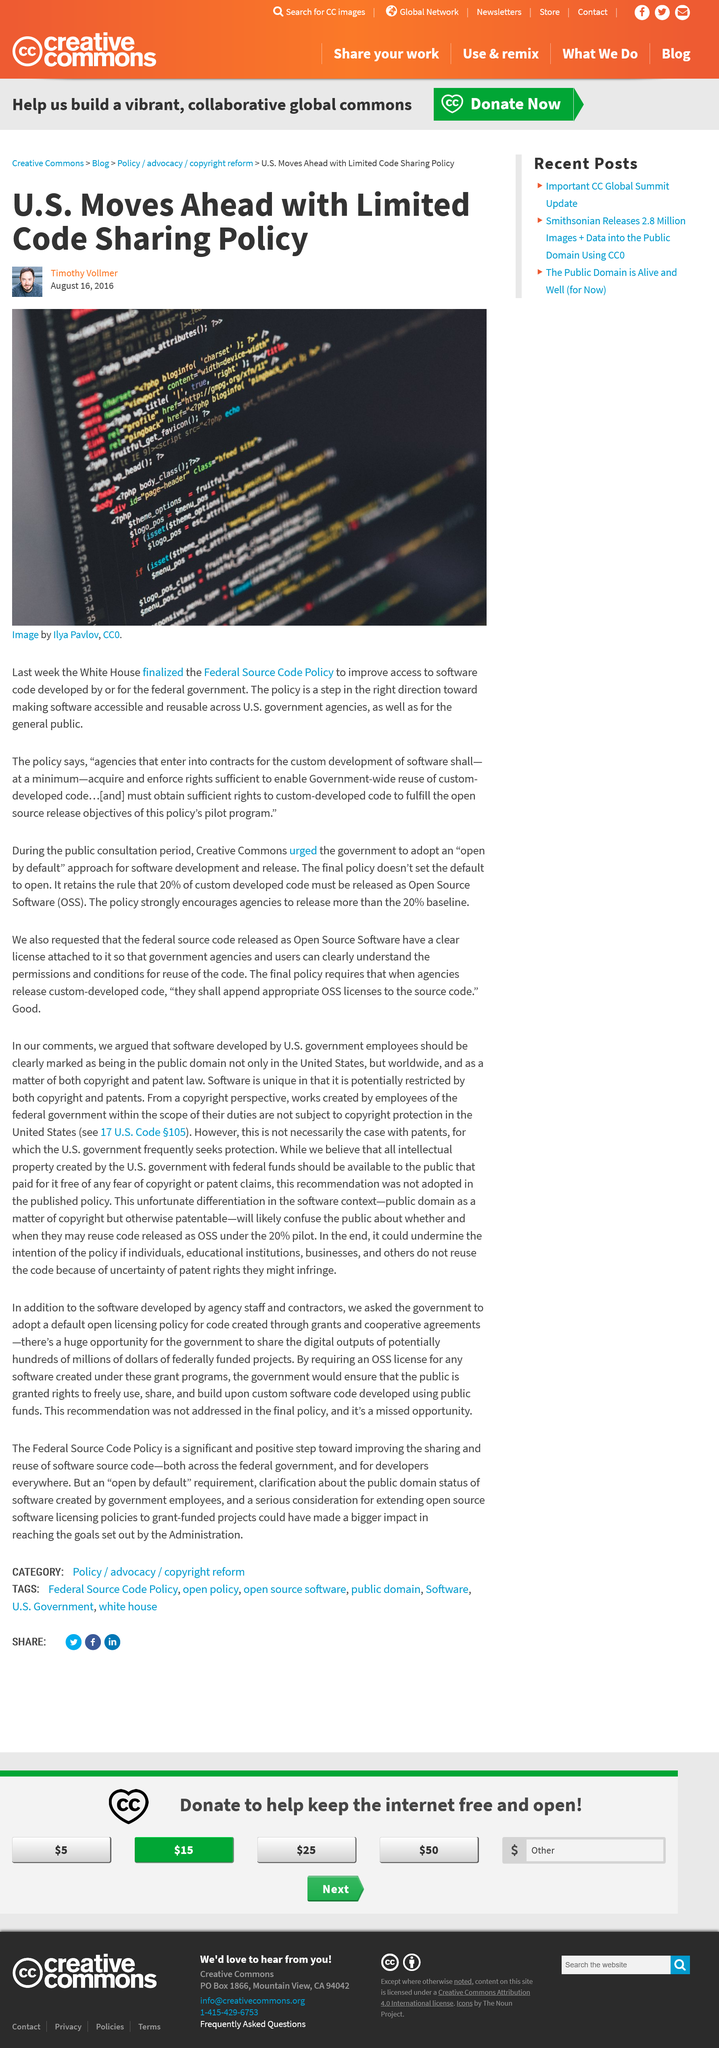Mention a couple of crucial points in this snapshot. The Federal Source Code Policy was published by the White House. The U.S. government agencies and the general public are reusing the software developed under the Small Business Innovation Research (SBIR) program. The author praises the policy and believes it to be a step in the right direction. 